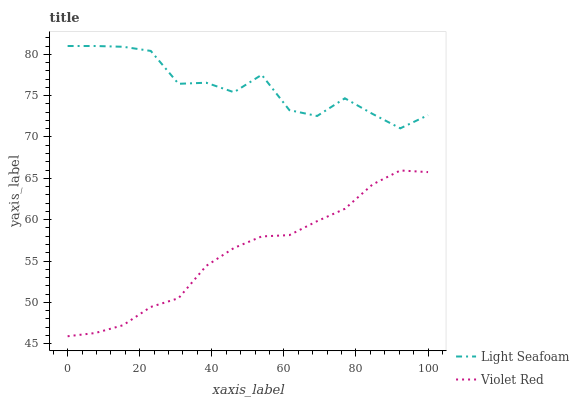Does Violet Red have the minimum area under the curve?
Answer yes or no. Yes. Does Light Seafoam have the maximum area under the curve?
Answer yes or no. Yes. Does Light Seafoam have the minimum area under the curve?
Answer yes or no. No. Is Violet Red the smoothest?
Answer yes or no. Yes. Is Light Seafoam the roughest?
Answer yes or no. Yes. Is Light Seafoam the smoothest?
Answer yes or no. No. Does Light Seafoam have the lowest value?
Answer yes or no. No. Does Light Seafoam have the highest value?
Answer yes or no. Yes. Is Violet Red less than Light Seafoam?
Answer yes or no. Yes. Is Light Seafoam greater than Violet Red?
Answer yes or no. Yes. Does Violet Red intersect Light Seafoam?
Answer yes or no. No. 